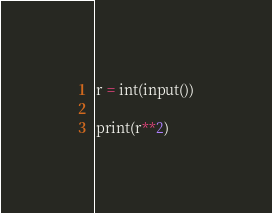<code> <loc_0><loc_0><loc_500><loc_500><_Python_>r = int(input())

print(r**2)</code> 